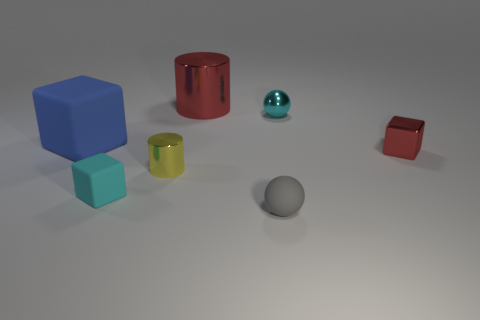What size is the object that is behind the cyan thing that is to the right of the tiny rubber thing that is left of the gray rubber thing?
Offer a very short reply. Large. How many other objects are there of the same size as the blue rubber thing?
Give a very brief answer. 1. What number of things are the same material as the yellow cylinder?
Your answer should be very brief. 3. What is the shape of the small matte thing that is in front of the tiny rubber block?
Keep it short and to the point. Sphere. Are the large blue object and the tiny block that is left of the tiny red shiny cube made of the same material?
Make the answer very short. Yes. Is there a red cylinder?
Your answer should be compact. Yes. Is there a matte cube that is in front of the matte block that is on the left side of the tiny cyan object that is left of the tiny cyan metal thing?
Offer a terse response. Yes. What number of small things are rubber spheres or red things?
Keep it short and to the point. 2. There is a cylinder that is the same size as the gray sphere; what color is it?
Ensure brevity in your answer.  Yellow. How many cylinders are left of the small yellow cylinder?
Provide a succinct answer. 0. 